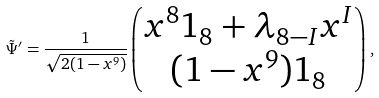<formula> <loc_0><loc_0><loc_500><loc_500>\tilde { \Psi } ^ { \prime } = \frac { 1 } { \sqrt { 2 ( 1 - x ^ { 9 } ) } } \begin{pmatrix} x ^ { 8 } 1 _ { 8 } + \lambda _ { 8 - I } x ^ { I } \\ ( 1 - x ^ { 9 } ) 1 _ { 8 } \end{pmatrix} ,</formula> 